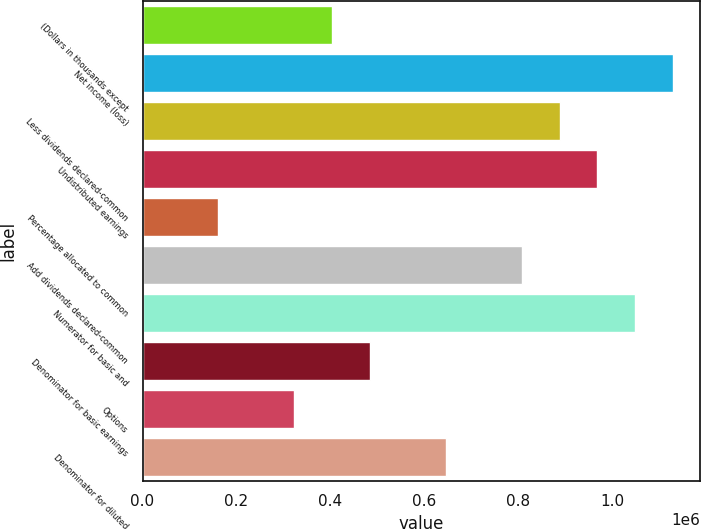<chart> <loc_0><loc_0><loc_500><loc_500><bar_chart><fcel>(Dollars in thousands except<fcel>Net income (loss)<fcel>Less dividends declared-common<fcel>Undistributed earnings<fcel>Percentage allocated to common<fcel>Add dividends declared-common<fcel>Numerator for basic and<fcel>Denominator for basic earnings<fcel>Options<fcel>Denominator for diluted<nl><fcel>403501<fcel>1.12978e+06<fcel>887687<fcel>968384<fcel>161408<fcel>806989<fcel>1.04908e+06<fcel>484199<fcel>322804<fcel>645594<nl></chart> 